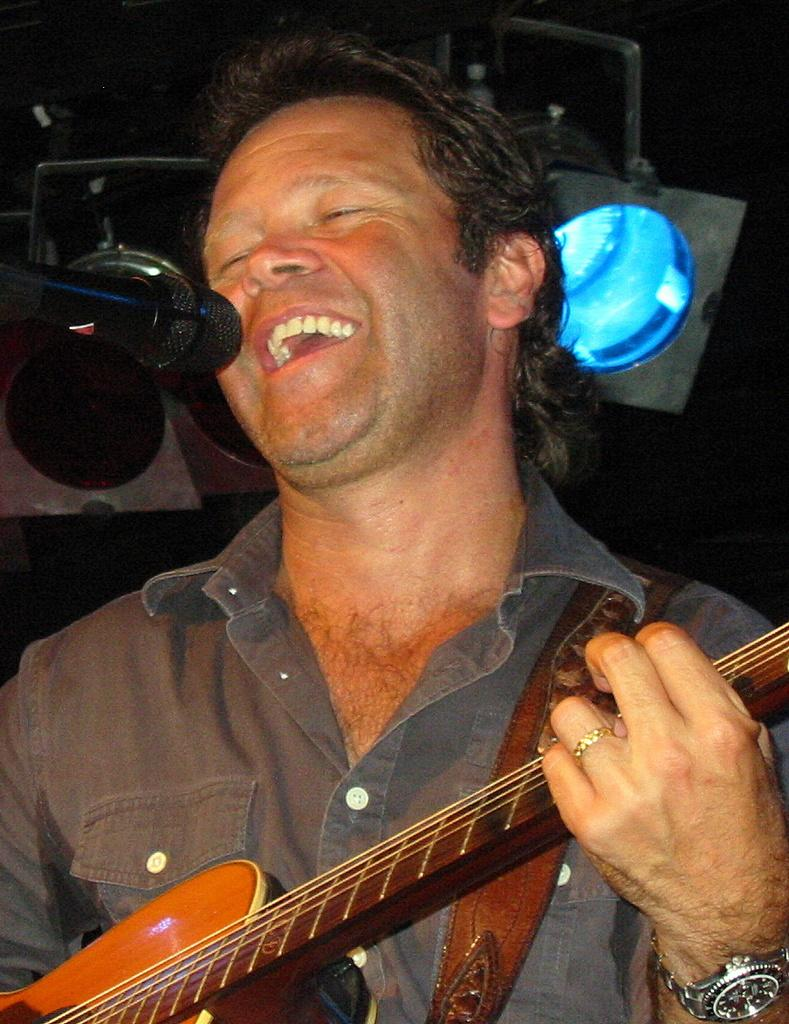What is the man in the image doing? The man in the image is singing and playing a guitar. What object is in front of the man? There is a microphone in front of the man. What can be seen behind the man? There is a light behind the man. What type of riddle is the man solving in the image? There is no riddle present in the image; the man is singing and playing a guitar. Can you tell me how many cabbages are on the man's head in the image? There are no cabbages present in the image; the man is focused on singing and playing a guitar. 